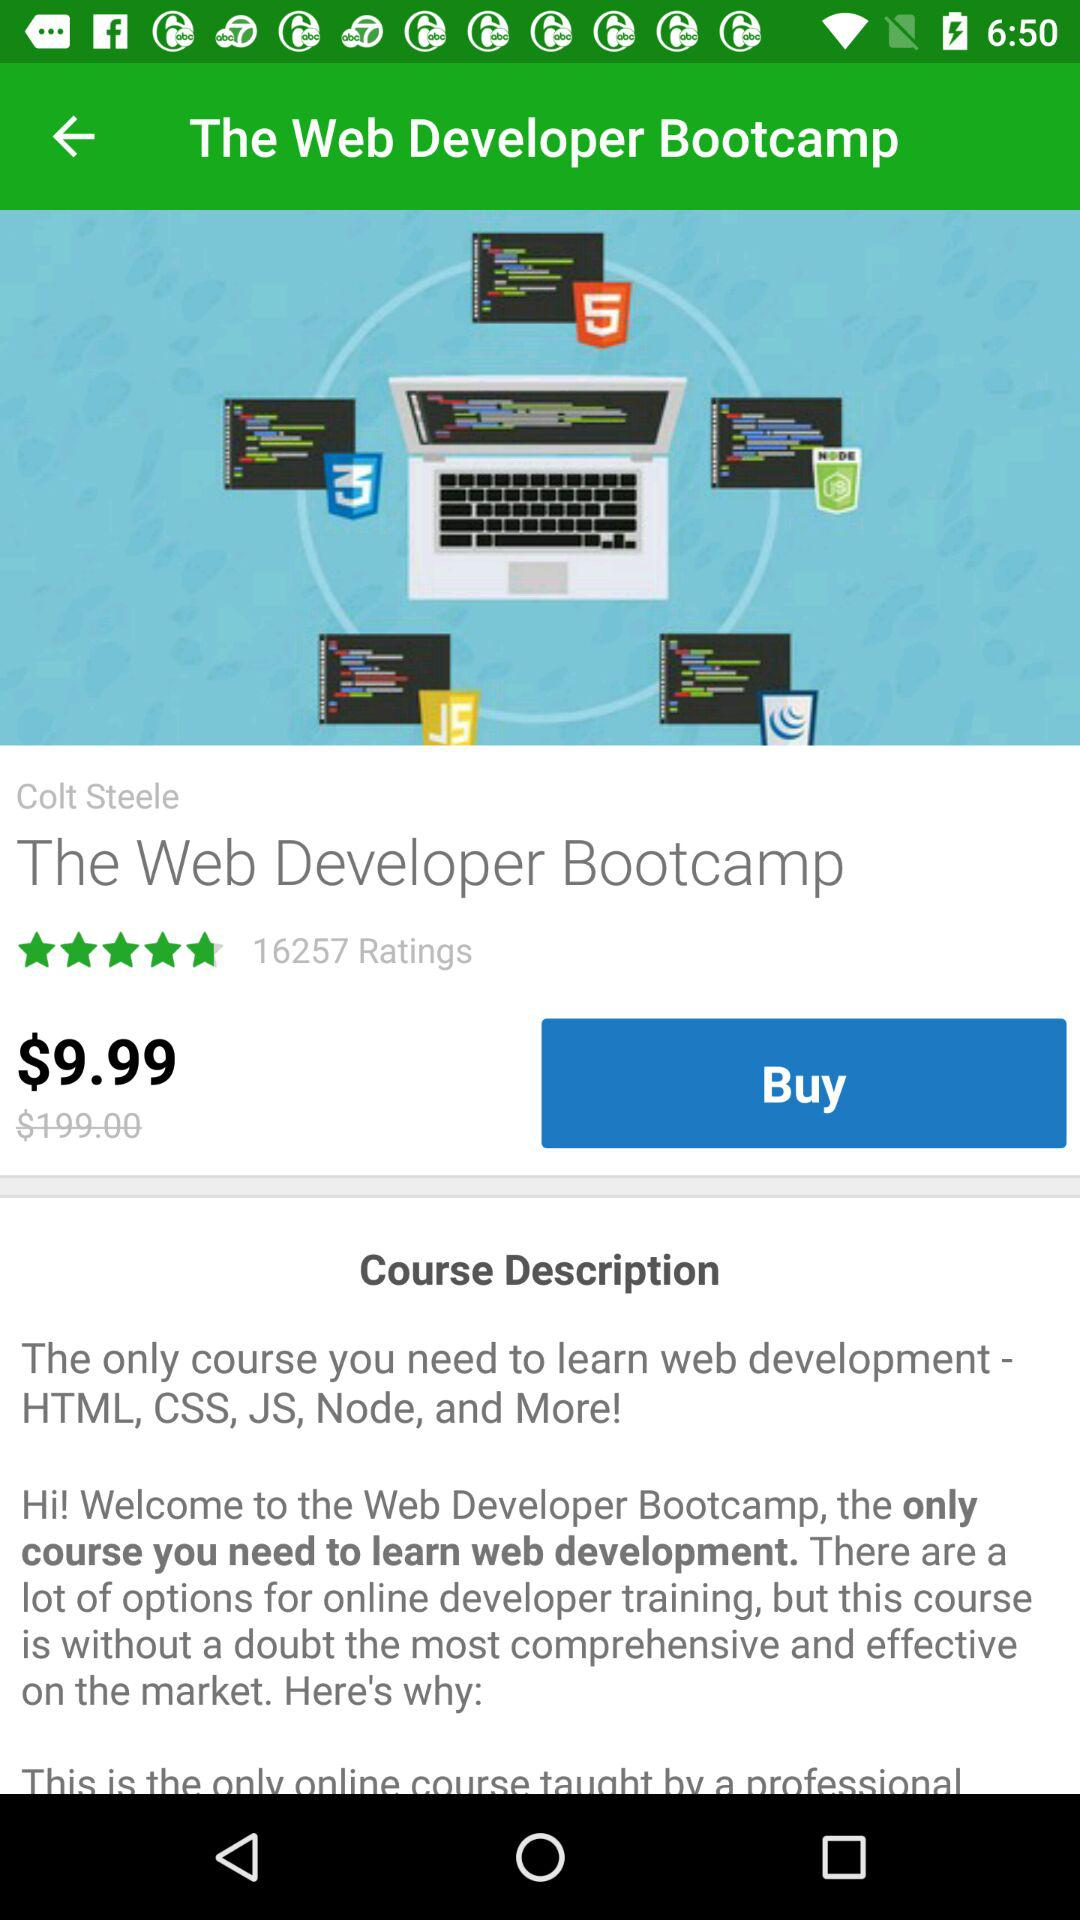What is the price of "The Web Developer Bootcamp"? The price of "The Web Developer Bootcamp" is $9.99. 